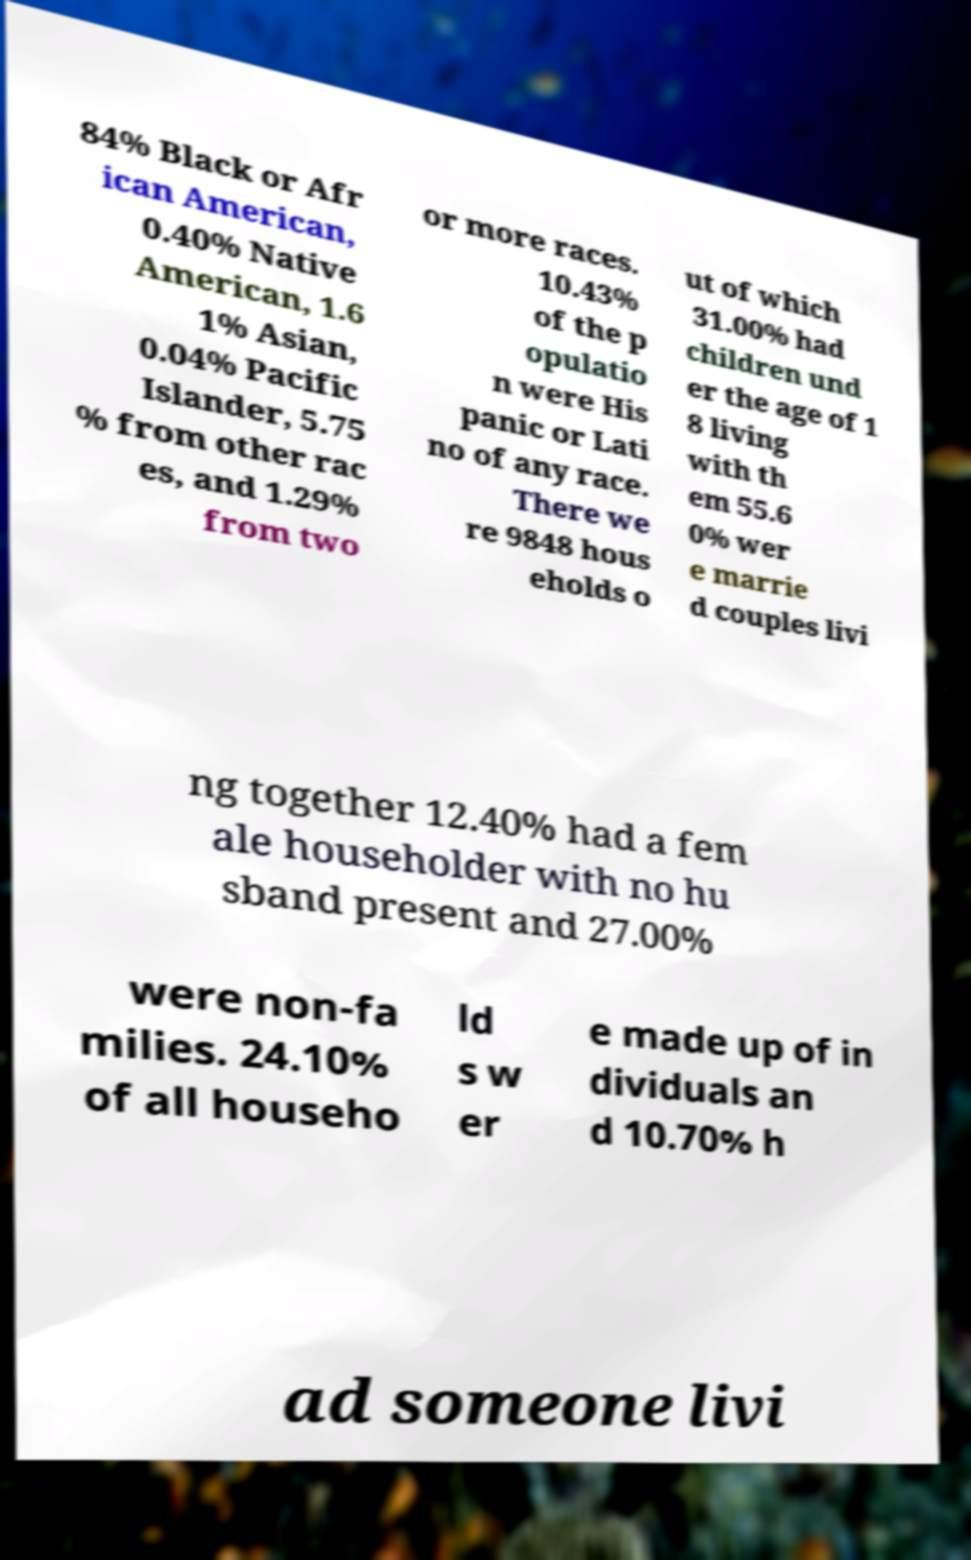For documentation purposes, I need the text within this image transcribed. Could you provide that? 84% Black or Afr ican American, 0.40% Native American, 1.6 1% Asian, 0.04% Pacific Islander, 5.75 % from other rac es, and 1.29% from two or more races. 10.43% of the p opulatio n were His panic or Lati no of any race. There we re 9848 hous eholds o ut of which 31.00% had children und er the age of 1 8 living with th em 55.6 0% wer e marrie d couples livi ng together 12.40% had a fem ale householder with no hu sband present and 27.00% were non-fa milies. 24.10% of all househo ld s w er e made up of in dividuals an d 10.70% h ad someone livi 